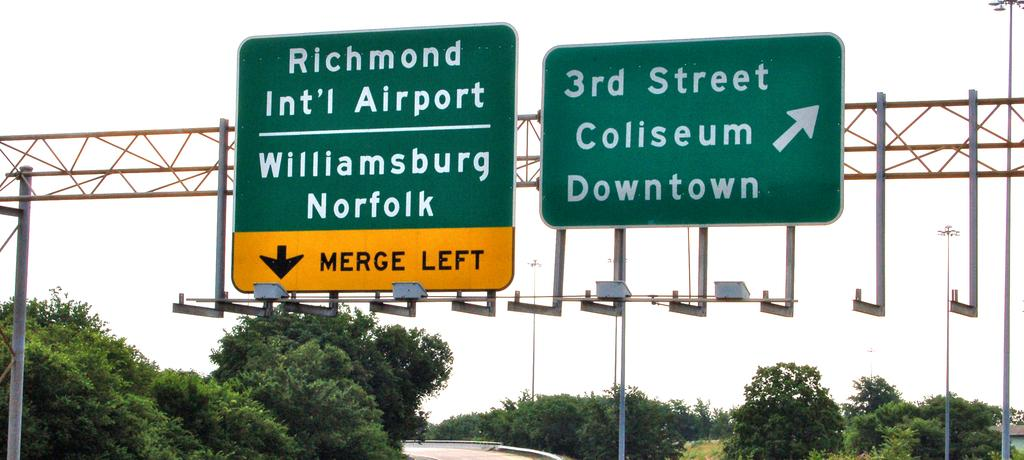<image>
Relay a brief, clear account of the picture shown. Highway signs show exits for 3rd street and for the airport. 